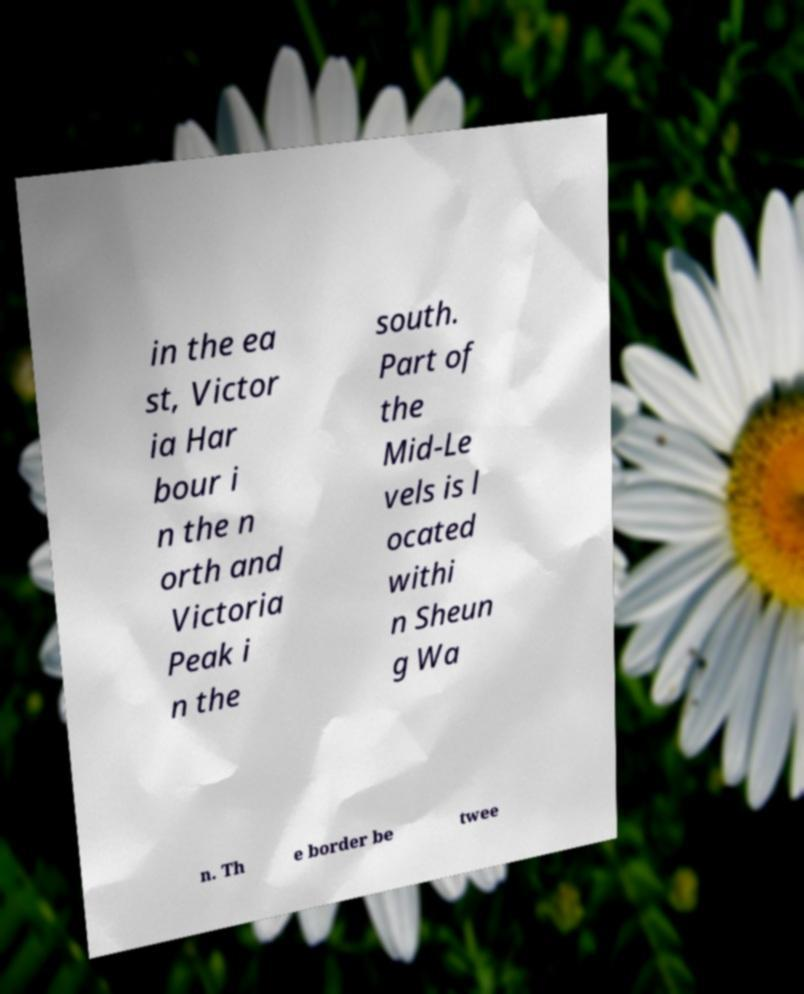Please identify and transcribe the text found in this image. in the ea st, Victor ia Har bour i n the n orth and Victoria Peak i n the south. Part of the Mid-Le vels is l ocated withi n Sheun g Wa n. Th e border be twee 